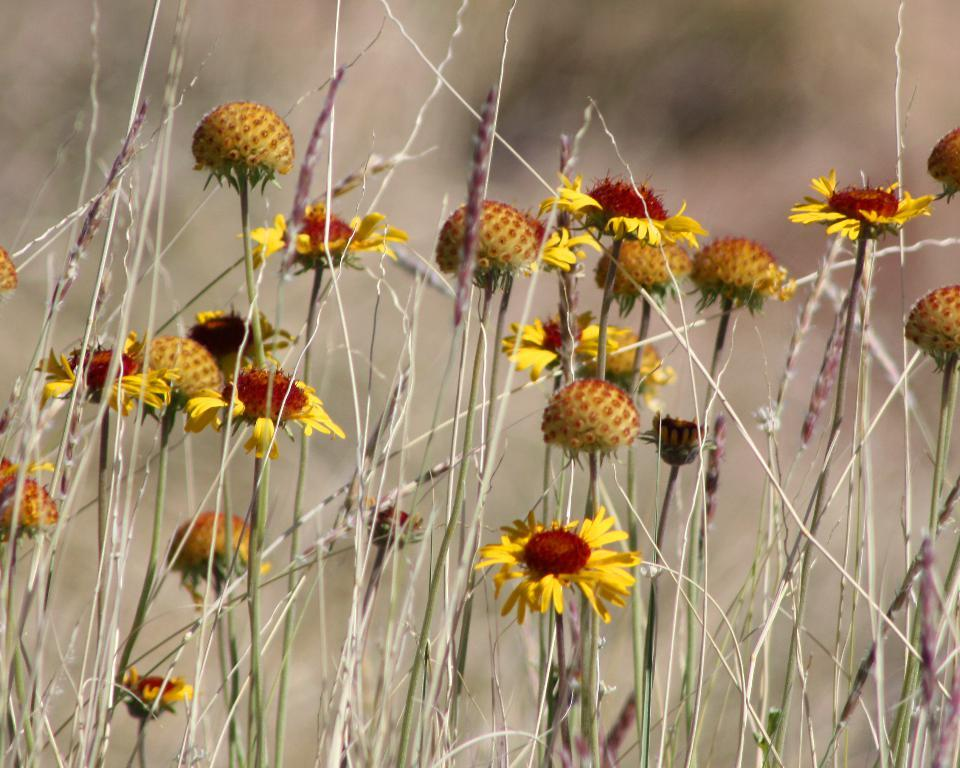What type of plants can be seen in the image? There are flowers in the image. Can you describe the structure of some of the flowers? Some flowers have stems, while others do not have petals. What can be observed about the background of the image? The background is blurry. How does the truck contribute to the learning process in the image? There is no truck present in the image, so it cannot contribute to the learning process. 